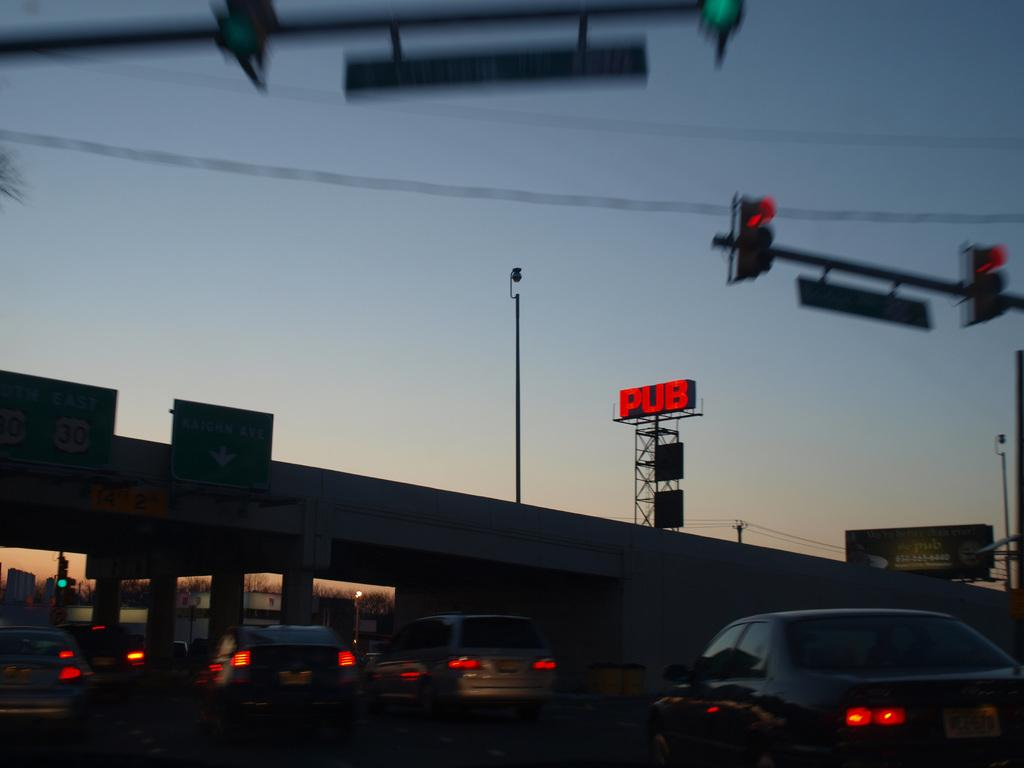Provide a one-sentence caption for the provided image. A busy street is shown with a bright red Pub sign above it. 